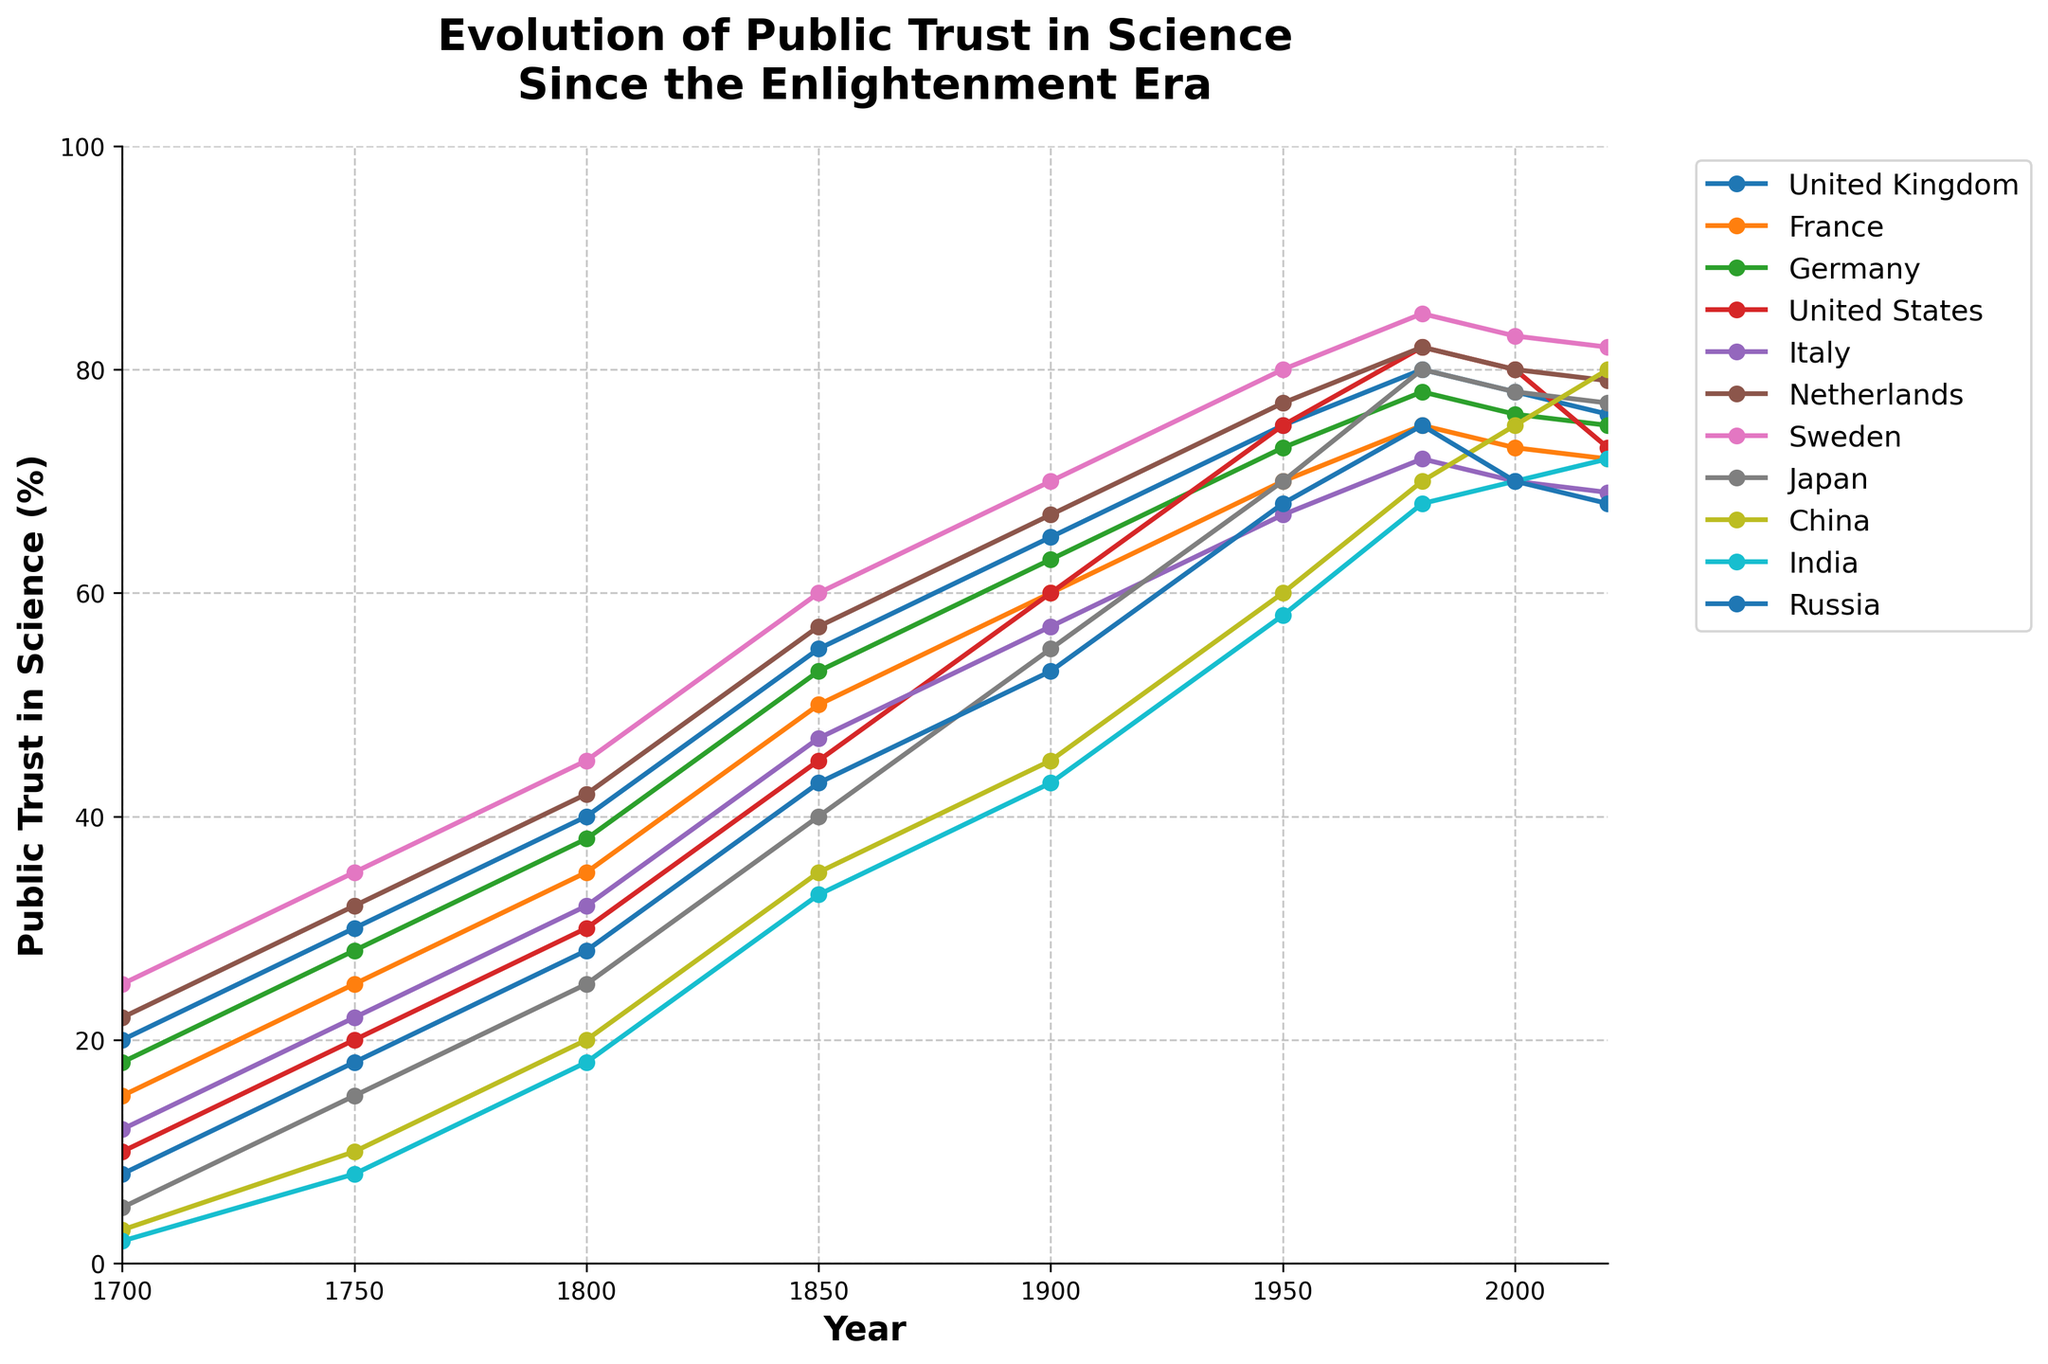What is the trend of public trust in science for Sweden from 1700 to 2020? Looking at the line representing Sweden, it starts around 25% in 1700 and steadily increases over time, reaching approximately 82% by 2020.
Answer: An overall increasing trend Which two countries had the highest and lowest trust in science in 2020? By examining the end points of each line in 2020, we see China has the highest trust at 80% and Russia has the lowest at 68%.
Answer: China has the highest at 80%, Russia has the lowest at 68% Which country showed the most significant increase in public trust in science from 1900 to 1950? Observing the slopes of the lines between 1900 and 1950, the United States has the steepest increase, growing from 60% to 75%.
Answer: United States Are there any countries where trust in science declined from 2000 to 2020? By comparing the heights of the lines at 2000 and 2020, the United Kingdom, Germany, and Russia show a slight decline.
Answer: United Kingdom, Germany, and Russia How did public trust in science in Japan change from 1700 to 1950? The line for Japan starts at 5% in 1700 and increases consistently to about 70% by 1950.
Answer: It increased from 5% to 70% Which countries have similar patterns in the evolution of public trust in science? United Kingdom and Germany, United States and Netherlands, France and Italy show similar patterns in their trajectories over time.
Answer: United Kingdom and Germany, United States and Netherlands, France and Italy What is the average public trust in science across all countries in 2000? Summing the values for 2000 (78 + 73 + 76 + 80 + 70 + 80 + 83 + 78 + 75 + 70 + 70) = 833, then dividing by 11 countries gives 833/11 ≈ 75.7%.
Answer: About 75.7% Which three countries had the highest increase in public trust in science from 1700 to 2020? Calculating the difference for each country between 1700 and 2020, China (80% - 3% = 77%), United States (73% - 10% = 63%), and Sweden (82% - 25% = 57%) had the highest increases.
Answer: China, United States, and Sweden From 1850 to 1900, how did the public trust in science in France compare to that in Germany? The line for France increased from 50% to 60%, while Germany's line increased from 53% to 63%. Germany shows a slightly steeper increase.
Answer: Germany had a steeper increase Considering the Enlightenment era (1700-1800), which country had the most consistent growth in public trust in science? Observing the line segments from 1700 to 1800, Sweden's line appears to increase the most consistently, from 25% to 45%.
Answer: Sweden 